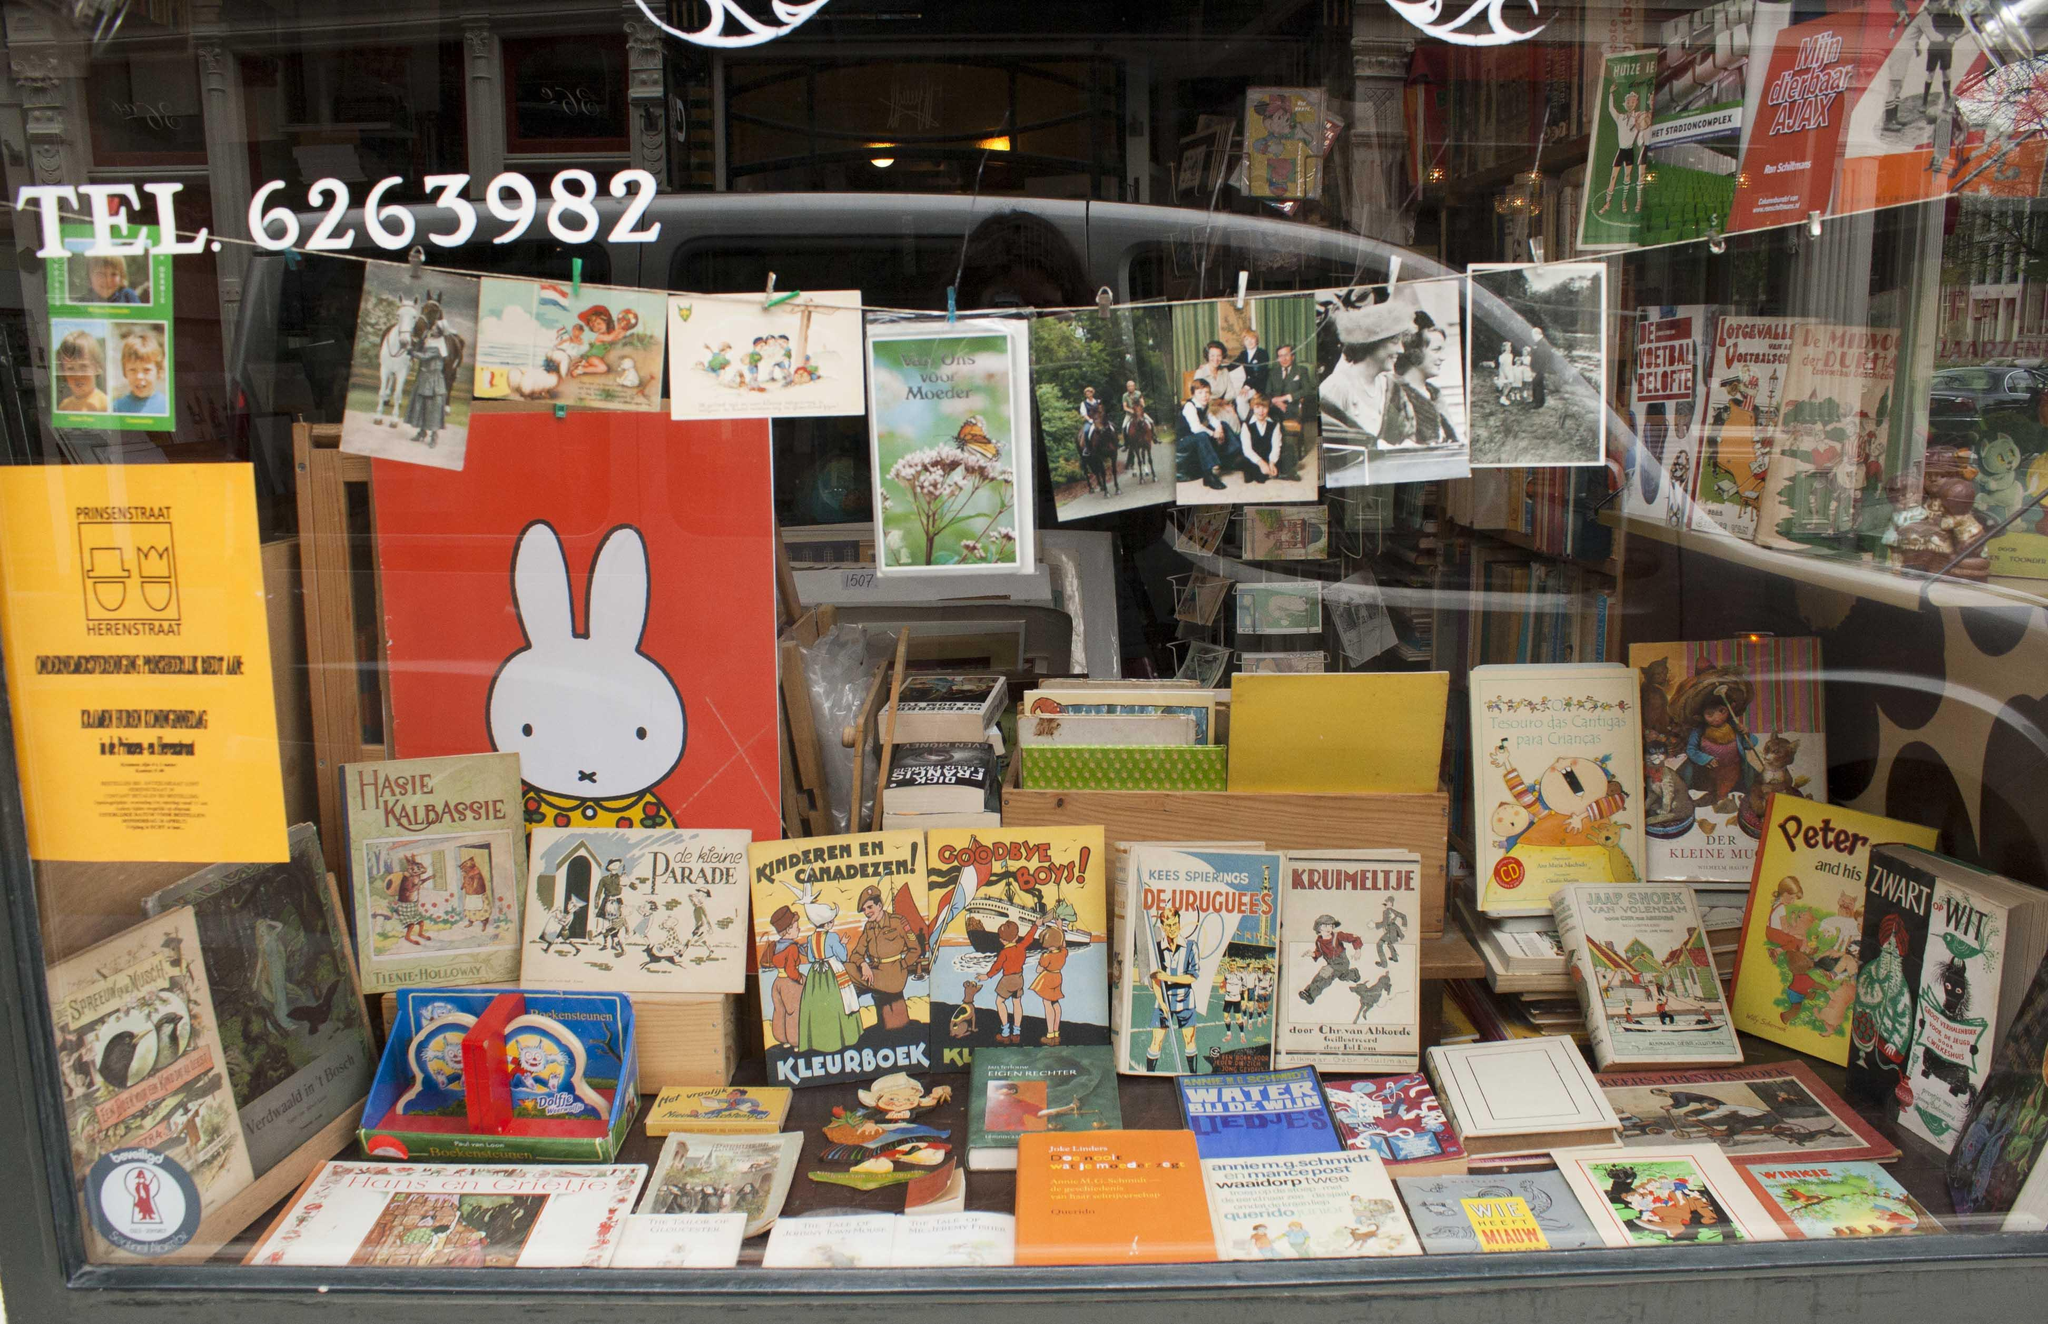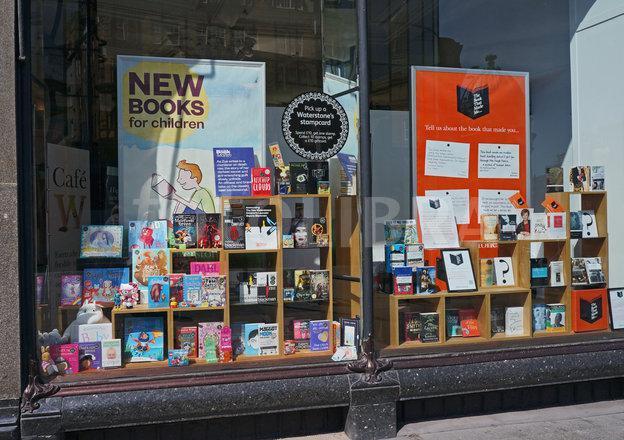The first image is the image on the left, the second image is the image on the right. Given the left and right images, does the statement "in both images, the storefronts show the store name on them" hold true? Answer yes or no. No. 